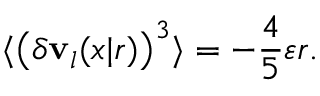Convert formula to latex. <formula><loc_0><loc_0><loc_500><loc_500>\langle \left ( \delta v _ { l } ( x | r ) \right ) ^ { 3 } \rangle = - \frac { 4 } { 5 } \varepsilon r .</formula> 